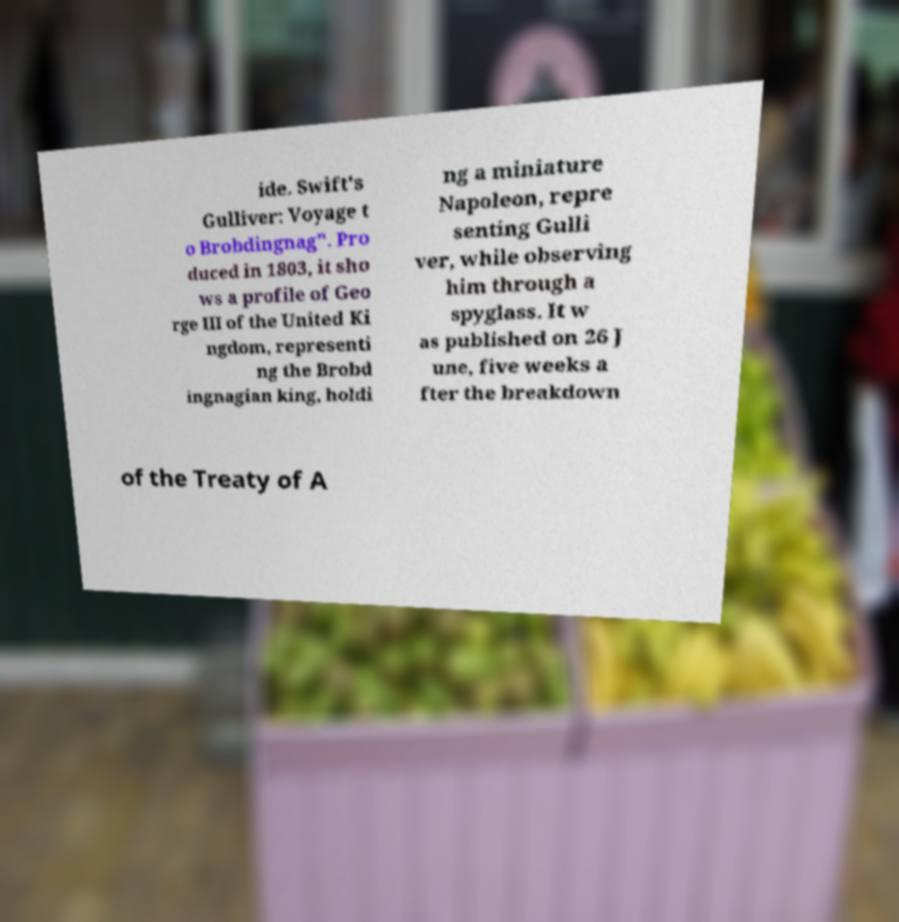I need the written content from this picture converted into text. Can you do that? ide. Swift's Gulliver: Voyage t o Brobdingnag". Pro duced in 1803, it sho ws a profile of Geo rge III of the United Ki ngdom, representi ng the Brobd ingnagian king, holdi ng a miniature Napoleon, repre senting Gulli ver, while observing him through a spyglass. It w as published on 26 J une, five weeks a fter the breakdown of the Treaty of A 